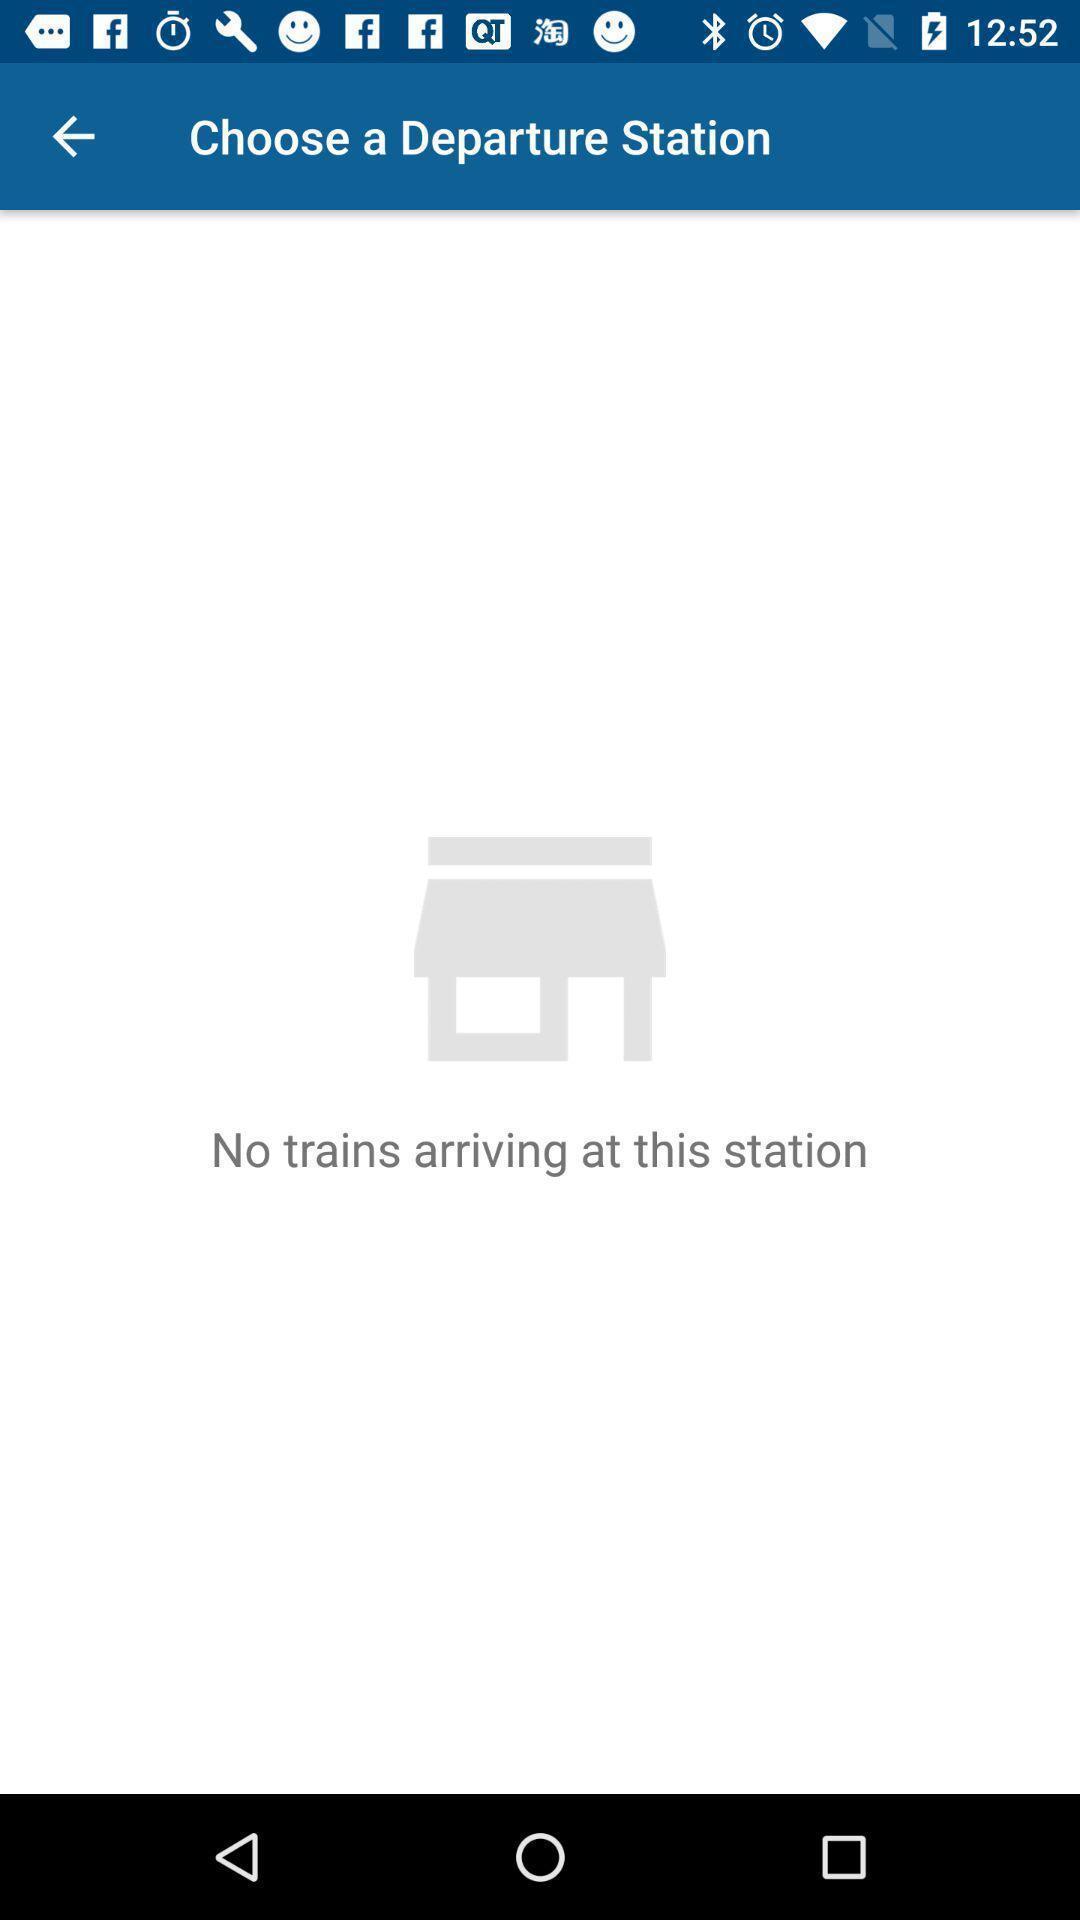What can you discern from this picture? Screen shows departure station details in a travel app. 